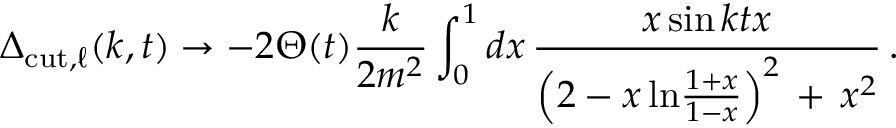<formula> <loc_0><loc_0><loc_500><loc_500>\Delta _ { c u t , \ell } ( k , t ) \rightarrow - 2 \Theta ( t ) \frac { k } { 2 m ^ { 2 } } \int _ { 0 } ^ { 1 } d x \, \frac { x \sin k t x } { \left ( 2 - x \, \ln \frac { 1 + x } { 1 - x } \right ) ^ { 2 } \, + \, x ^ { 2 } } \, .</formula> 